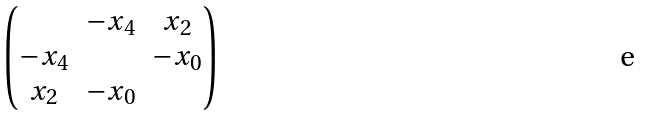<formula> <loc_0><loc_0><loc_500><loc_500>\begin{pmatrix} & - x _ { 4 } & x _ { 2 } \\ - x _ { 4 } & & - x _ { 0 } \\ x _ { 2 } & - x _ { 0 } & \end{pmatrix}</formula> 